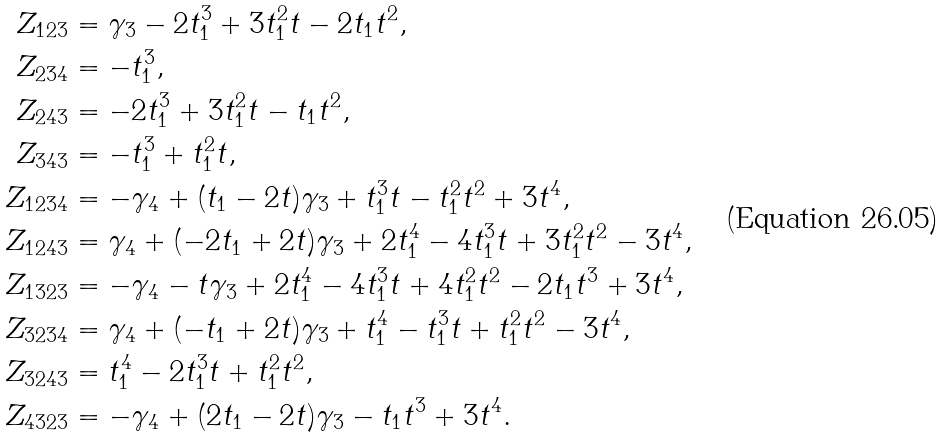<formula> <loc_0><loc_0><loc_500><loc_500>Z _ { 1 2 3 } & = \gamma _ { 3 } - 2 t _ { 1 } ^ { 3 } + 3 t _ { 1 } ^ { 2 } t - 2 t _ { 1 } t ^ { 2 } , \\ Z _ { 2 3 4 } & = - t _ { 1 } ^ { 3 } , \\ Z _ { 2 4 3 } & = - 2 t _ { 1 } ^ { 3 } + 3 t _ { 1 } ^ { 2 } t - t _ { 1 } t ^ { 2 } , \\ Z _ { 3 4 3 } & = - t _ { 1 } ^ { 3 } + t _ { 1 } ^ { 2 } t , \\ Z _ { 1 2 3 4 } & = - \gamma _ { 4 } + ( t _ { 1 } - 2 t ) \gamma _ { 3 } + t _ { 1 } ^ { 3 } t - t _ { 1 } ^ { 2 } t ^ { 2 } + 3 t ^ { 4 } , \\ Z _ { 1 2 4 3 } & = \gamma _ { 4 } + ( - 2 t _ { 1 } + 2 t ) \gamma _ { 3 } + 2 t _ { 1 } ^ { 4 } - 4 t _ { 1 } ^ { 3 } t + 3 t _ { 1 } ^ { 2 } t ^ { 2 } - 3 t ^ { 4 } , \\ Z _ { 1 3 2 3 } & = - \gamma _ { 4 } - t \gamma _ { 3 } + 2 t _ { 1 } ^ { 4 } - 4 t _ { 1 } ^ { 3 } t + 4 t _ { 1 } ^ { 2 } t ^ { 2 } - 2 t _ { 1 } t ^ { 3 } + 3 t ^ { 4 } , \\ Z _ { 3 2 3 4 } & = \gamma _ { 4 } + ( - t _ { 1 } + 2 t ) \gamma _ { 3 } + t _ { 1 } ^ { 4 } - t _ { 1 } ^ { 3 } t + t _ { 1 } ^ { 2 } t ^ { 2 } - 3 t ^ { 4 } , \\ Z _ { 3 2 4 3 } & = t _ { 1 } ^ { 4 } - 2 t _ { 1 } ^ { 3 } t + t _ { 1 } ^ { 2 } t ^ { 2 } , \\ Z _ { 4 3 2 3 } & = - \gamma _ { 4 } + ( 2 t _ { 1 } - 2 t ) \gamma _ { 3 } - t _ { 1 } t ^ { 3 } + 3 t ^ { 4 } .</formula> 